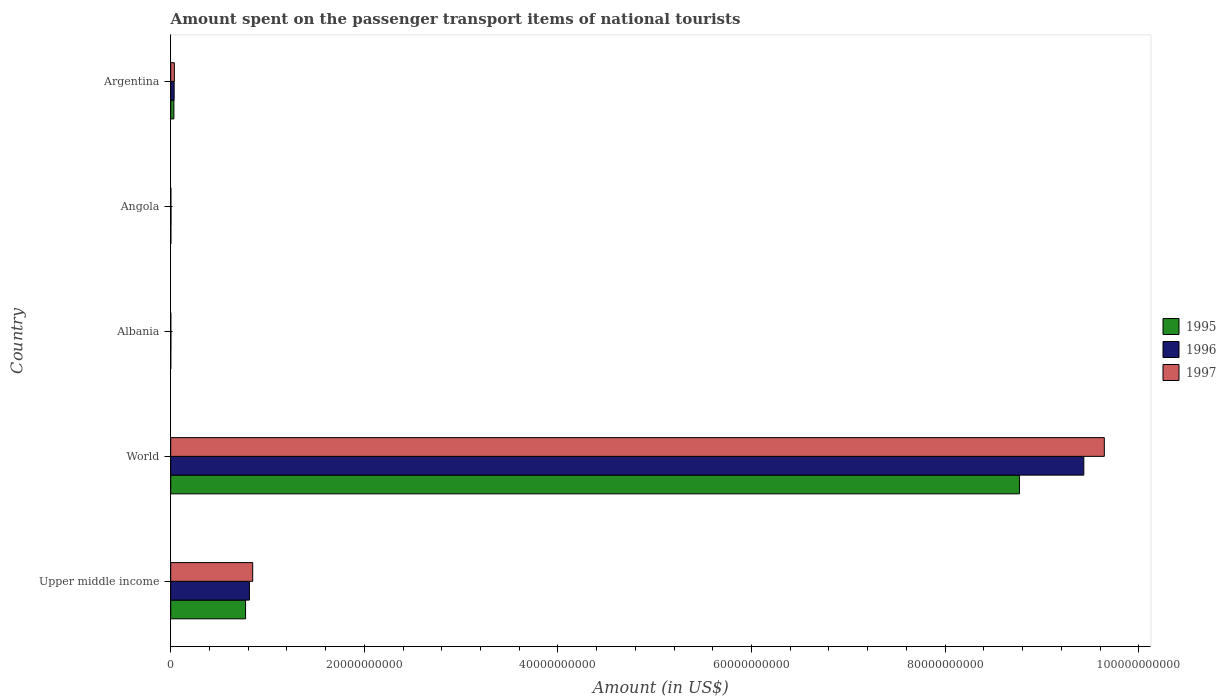How many different coloured bars are there?
Your response must be concise. 3. How many groups of bars are there?
Your answer should be compact. 5. What is the label of the 3rd group of bars from the top?
Offer a terse response. Albania. What is the amount spent on the passenger transport items of national tourists in 1997 in World?
Keep it short and to the point. 9.64e+1. Across all countries, what is the maximum amount spent on the passenger transport items of national tourists in 1996?
Ensure brevity in your answer.  9.43e+1. Across all countries, what is the minimum amount spent on the passenger transport items of national tourists in 1995?
Your answer should be very brief. 5.40e+06. In which country was the amount spent on the passenger transport items of national tourists in 1997 maximum?
Provide a short and direct response. World. In which country was the amount spent on the passenger transport items of national tourists in 1996 minimum?
Keep it short and to the point. Albania. What is the total amount spent on the passenger transport items of national tourists in 1995 in the graph?
Keep it short and to the point. 9.58e+1. What is the difference between the amount spent on the passenger transport items of national tourists in 1997 in Albania and that in World?
Make the answer very short. -9.64e+1. What is the difference between the amount spent on the passenger transport items of national tourists in 1995 in Albania and the amount spent on the passenger transport items of national tourists in 1996 in Upper middle income?
Provide a short and direct response. -8.13e+09. What is the average amount spent on the passenger transport items of national tourists in 1997 per country?
Make the answer very short. 2.11e+1. What is the difference between the amount spent on the passenger transport items of national tourists in 1995 and amount spent on the passenger transport items of national tourists in 1996 in Argentina?
Your response must be concise. -2.60e+07. In how many countries, is the amount spent on the passenger transport items of national tourists in 1996 greater than 72000000000 US$?
Provide a succinct answer. 1. What is the ratio of the amount spent on the passenger transport items of national tourists in 1996 in Albania to that in Upper middle income?
Keep it short and to the point. 0. Is the amount spent on the passenger transport items of national tourists in 1995 in Argentina less than that in World?
Your answer should be compact. Yes. Is the difference between the amount spent on the passenger transport items of national tourists in 1995 in Angola and Upper middle income greater than the difference between the amount spent on the passenger transport items of national tourists in 1996 in Angola and Upper middle income?
Your response must be concise. Yes. What is the difference between the highest and the second highest amount spent on the passenger transport items of national tourists in 1996?
Keep it short and to the point. 8.62e+1. What is the difference between the highest and the lowest amount spent on the passenger transport items of national tourists in 1995?
Your answer should be very brief. 8.77e+1. Is the sum of the amount spent on the passenger transport items of national tourists in 1996 in Albania and Upper middle income greater than the maximum amount spent on the passenger transport items of national tourists in 1995 across all countries?
Offer a very short reply. No. What does the 1st bar from the top in Albania represents?
Your answer should be compact. 1997. What does the 2nd bar from the bottom in Upper middle income represents?
Provide a succinct answer. 1996. Is it the case that in every country, the sum of the amount spent on the passenger transport items of national tourists in 1997 and amount spent on the passenger transport items of national tourists in 1996 is greater than the amount spent on the passenger transport items of national tourists in 1995?
Give a very brief answer. Yes. Are all the bars in the graph horizontal?
Provide a short and direct response. Yes. How many countries are there in the graph?
Make the answer very short. 5. Where does the legend appear in the graph?
Your response must be concise. Center right. How many legend labels are there?
Make the answer very short. 3. How are the legend labels stacked?
Offer a terse response. Vertical. What is the title of the graph?
Provide a succinct answer. Amount spent on the passenger transport items of national tourists. Does "1991" appear as one of the legend labels in the graph?
Keep it short and to the point. No. What is the label or title of the Y-axis?
Give a very brief answer. Country. What is the Amount (in US$) of 1995 in Upper middle income?
Provide a short and direct response. 7.73e+09. What is the Amount (in US$) in 1996 in Upper middle income?
Provide a short and direct response. 8.13e+09. What is the Amount (in US$) of 1997 in Upper middle income?
Your answer should be very brief. 8.47e+09. What is the Amount (in US$) in 1995 in World?
Your response must be concise. 8.77e+1. What is the Amount (in US$) of 1996 in World?
Make the answer very short. 9.43e+1. What is the Amount (in US$) of 1997 in World?
Offer a very short reply. 9.64e+1. What is the Amount (in US$) in 1995 in Albania?
Offer a terse response. 5.40e+06. What is the Amount (in US$) of 1996 in Albania?
Make the answer very short. 1.68e+07. What is the Amount (in US$) in 1997 in Albania?
Ensure brevity in your answer.  6.60e+06. What is the Amount (in US$) of 1995 in Angola?
Your answer should be very brief. 1.70e+07. What is the Amount (in US$) in 1996 in Angola?
Provide a succinct answer. 2.90e+07. What is the Amount (in US$) in 1997 in Angola?
Your answer should be compact. 1.50e+07. What is the Amount (in US$) of 1995 in Argentina?
Your answer should be very brief. 3.28e+08. What is the Amount (in US$) in 1996 in Argentina?
Provide a succinct answer. 3.54e+08. What is the Amount (in US$) of 1997 in Argentina?
Provide a succinct answer. 3.75e+08. Across all countries, what is the maximum Amount (in US$) of 1995?
Give a very brief answer. 8.77e+1. Across all countries, what is the maximum Amount (in US$) in 1996?
Make the answer very short. 9.43e+1. Across all countries, what is the maximum Amount (in US$) in 1997?
Ensure brevity in your answer.  9.64e+1. Across all countries, what is the minimum Amount (in US$) in 1995?
Give a very brief answer. 5.40e+06. Across all countries, what is the minimum Amount (in US$) in 1996?
Your answer should be compact. 1.68e+07. Across all countries, what is the minimum Amount (in US$) of 1997?
Offer a terse response. 6.60e+06. What is the total Amount (in US$) of 1995 in the graph?
Your answer should be compact. 9.58e+1. What is the total Amount (in US$) in 1996 in the graph?
Keep it short and to the point. 1.03e+11. What is the total Amount (in US$) of 1997 in the graph?
Provide a succinct answer. 1.05e+11. What is the difference between the Amount (in US$) in 1995 in Upper middle income and that in World?
Provide a short and direct response. -7.99e+1. What is the difference between the Amount (in US$) of 1996 in Upper middle income and that in World?
Make the answer very short. -8.62e+1. What is the difference between the Amount (in US$) of 1997 in Upper middle income and that in World?
Provide a succinct answer. -8.80e+1. What is the difference between the Amount (in US$) of 1995 in Upper middle income and that in Albania?
Provide a succinct answer. 7.73e+09. What is the difference between the Amount (in US$) in 1996 in Upper middle income and that in Albania?
Offer a terse response. 8.11e+09. What is the difference between the Amount (in US$) in 1997 in Upper middle income and that in Albania?
Provide a short and direct response. 8.46e+09. What is the difference between the Amount (in US$) of 1995 in Upper middle income and that in Angola?
Your response must be concise. 7.72e+09. What is the difference between the Amount (in US$) in 1996 in Upper middle income and that in Angola?
Offer a very short reply. 8.10e+09. What is the difference between the Amount (in US$) of 1997 in Upper middle income and that in Angola?
Keep it short and to the point. 8.45e+09. What is the difference between the Amount (in US$) of 1995 in Upper middle income and that in Argentina?
Your response must be concise. 7.41e+09. What is the difference between the Amount (in US$) in 1996 in Upper middle income and that in Argentina?
Ensure brevity in your answer.  7.78e+09. What is the difference between the Amount (in US$) in 1997 in Upper middle income and that in Argentina?
Provide a short and direct response. 8.09e+09. What is the difference between the Amount (in US$) of 1995 in World and that in Albania?
Offer a terse response. 8.77e+1. What is the difference between the Amount (in US$) in 1996 in World and that in Albania?
Make the answer very short. 9.43e+1. What is the difference between the Amount (in US$) of 1997 in World and that in Albania?
Provide a succinct answer. 9.64e+1. What is the difference between the Amount (in US$) in 1995 in World and that in Angola?
Offer a terse response. 8.77e+1. What is the difference between the Amount (in US$) of 1996 in World and that in Angola?
Your response must be concise. 9.43e+1. What is the difference between the Amount (in US$) of 1997 in World and that in Angola?
Provide a short and direct response. 9.64e+1. What is the difference between the Amount (in US$) of 1995 in World and that in Argentina?
Offer a very short reply. 8.73e+1. What is the difference between the Amount (in US$) of 1996 in World and that in Argentina?
Your answer should be compact. 9.40e+1. What is the difference between the Amount (in US$) of 1997 in World and that in Argentina?
Offer a very short reply. 9.61e+1. What is the difference between the Amount (in US$) in 1995 in Albania and that in Angola?
Give a very brief answer. -1.16e+07. What is the difference between the Amount (in US$) of 1996 in Albania and that in Angola?
Keep it short and to the point. -1.22e+07. What is the difference between the Amount (in US$) in 1997 in Albania and that in Angola?
Give a very brief answer. -8.40e+06. What is the difference between the Amount (in US$) in 1995 in Albania and that in Argentina?
Offer a terse response. -3.23e+08. What is the difference between the Amount (in US$) of 1996 in Albania and that in Argentina?
Your answer should be compact. -3.37e+08. What is the difference between the Amount (in US$) of 1997 in Albania and that in Argentina?
Offer a terse response. -3.69e+08. What is the difference between the Amount (in US$) of 1995 in Angola and that in Argentina?
Your response must be concise. -3.11e+08. What is the difference between the Amount (in US$) of 1996 in Angola and that in Argentina?
Your answer should be compact. -3.25e+08. What is the difference between the Amount (in US$) of 1997 in Angola and that in Argentina?
Keep it short and to the point. -3.60e+08. What is the difference between the Amount (in US$) in 1995 in Upper middle income and the Amount (in US$) in 1996 in World?
Your answer should be compact. -8.66e+1. What is the difference between the Amount (in US$) in 1995 in Upper middle income and the Amount (in US$) in 1997 in World?
Keep it short and to the point. -8.87e+1. What is the difference between the Amount (in US$) in 1996 in Upper middle income and the Amount (in US$) in 1997 in World?
Provide a succinct answer. -8.83e+1. What is the difference between the Amount (in US$) of 1995 in Upper middle income and the Amount (in US$) of 1996 in Albania?
Make the answer very short. 7.72e+09. What is the difference between the Amount (in US$) of 1995 in Upper middle income and the Amount (in US$) of 1997 in Albania?
Offer a terse response. 7.73e+09. What is the difference between the Amount (in US$) of 1996 in Upper middle income and the Amount (in US$) of 1997 in Albania?
Make the answer very short. 8.12e+09. What is the difference between the Amount (in US$) of 1995 in Upper middle income and the Amount (in US$) of 1996 in Angola?
Your answer should be very brief. 7.70e+09. What is the difference between the Amount (in US$) in 1995 in Upper middle income and the Amount (in US$) in 1997 in Angola?
Make the answer very short. 7.72e+09. What is the difference between the Amount (in US$) of 1996 in Upper middle income and the Amount (in US$) of 1997 in Angola?
Your answer should be very brief. 8.12e+09. What is the difference between the Amount (in US$) in 1995 in Upper middle income and the Amount (in US$) in 1996 in Argentina?
Make the answer very short. 7.38e+09. What is the difference between the Amount (in US$) of 1995 in Upper middle income and the Amount (in US$) of 1997 in Argentina?
Give a very brief answer. 7.36e+09. What is the difference between the Amount (in US$) of 1996 in Upper middle income and the Amount (in US$) of 1997 in Argentina?
Offer a terse response. 7.76e+09. What is the difference between the Amount (in US$) of 1995 in World and the Amount (in US$) of 1996 in Albania?
Your answer should be compact. 8.77e+1. What is the difference between the Amount (in US$) in 1995 in World and the Amount (in US$) in 1997 in Albania?
Give a very brief answer. 8.77e+1. What is the difference between the Amount (in US$) of 1996 in World and the Amount (in US$) of 1997 in Albania?
Offer a very short reply. 9.43e+1. What is the difference between the Amount (in US$) in 1995 in World and the Amount (in US$) in 1996 in Angola?
Ensure brevity in your answer.  8.76e+1. What is the difference between the Amount (in US$) in 1995 in World and the Amount (in US$) in 1997 in Angola?
Keep it short and to the point. 8.77e+1. What is the difference between the Amount (in US$) in 1996 in World and the Amount (in US$) in 1997 in Angola?
Offer a very short reply. 9.43e+1. What is the difference between the Amount (in US$) in 1995 in World and the Amount (in US$) in 1996 in Argentina?
Your answer should be very brief. 8.73e+1. What is the difference between the Amount (in US$) in 1995 in World and the Amount (in US$) in 1997 in Argentina?
Your response must be concise. 8.73e+1. What is the difference between the Amount (in US$) in 1996 in World and the Amount (in US$) in 1997 in Argentina?
Offer a very short reply. 9.39e+1. What is the difference between the Amount (in US$) of 1995 in Albania and the Amount (in US$) of 1996 in Angola?
Provide a succinct answer. -2.36e+07. What is the difference between the Amount (in US$) of 1995 in Albania and the Amount (in US$) of 1997 in Angola?
Offer a very short reply. -9.60e+06. What is the difference between the Amount (in US$) in 1996 in Albania and the Amount (in US$) in 1997 in Angola?
Give a very brief answer. 1.80e+06. What is the difference between the Amount (in US$) in 1995 in Albania and the Amount (in US$) in 1996 in Argentina?
Ensure brevity in your answer.  -3.49e+08. What is the difference between the Amount (in US$) of 1995 in Albania and the Amount (in US$) of 1997 in Argentina?
Make the answer very short. -3.70e+08. What is the difference between the Amount (in US$) in 1996 in Albania and the Amount (in US$) in 1997 in Argentina?
Provide a short and direct response. -3.59e+08. What is the difference between the Amount (in US$) of 1995 in Angola and the Amount (in US$) of 1996 in Argentina?
Give a very brief answer. -3.37e+08. What is the difference between the Amount (in US$) in 1995 in Angola and the Amount (in US$) in 1997 in Argentina?
Your response must be concise. -3.58e+08. What is the difference between the Amount (in US$) of 1996 in Angola and the Amount (in US$) of 1997 in Argentina?
Make the answer very short. -3.46e+08. What is the average Amount (in US$) in 1995 per country?
Provide a short and direct response. 1.92e+1. What is the average Amount (in US$) of 1996 per country?
Provide a succinct answer. 2.06e+1. What is the average Amount (in US$) in 1997 per country?
Your answer should be very brief. 2.11e+1. What is the difference between the Amount (in US$) in 1995 and Amount (in US$) in 1996 in Upper middle income?
Give a very brief answer. -3.97e+08. What is the difference between the Amount (in US$) of 1995 and Amount (in US$) of 1997 in Upper middle income?
Give a very brief answer. -7.36e+08. What is the difference between the Amount (in US$) of 1996 and Amount (in US$) of 1997 in Upper middle income?
Give a very brief answer. -3.39e+08. What is the difference between the Amount (in US$) of 1995 and Amount (in US$) of 1996 in World?
Keep it short and to the point. -6.65e+09. What is the difference between the Amount (in US$) of 1995 and Amount (in US$) of 1997 in World?
Give a very brief answer. -8.77e+09. What is the difference between the Amount (in US$) of 1996 and Amount (in US$) of 1997 in World?
Your answer should be very brief. -2.12e+09. What is the difference between the Amount (in US$) in 1995 and Amount (in US$) in 1996 in Albania?
Make the answer very short. -1.14e+07. What is the difference between the Amount (in US$) of 1995 and Amount (in US$) of 1997 in Albania?
Provide a succinct answer. -1.20e+06. What is the difference between the Amount (in US$) in 1996 and Amount (in US$) in 1997 in Albania?
Your answer should be very brief. 1.02e+07. What is the difference between the Amount (in US$) in 1995 and Amount (in US$) in 1996 in Angola?
Offer a terse response. -1.20e+07. What is the difference between the Amount (in US$) of 1996 and Amount (in US$) of 1997 in Angola?
Provide a succinct answer. 1.40e+07. What is the difference between the Amount (in US$) of 1995 and Amount (in US$) of 1996 in Argentina?
Your answer should be very brief. -2.60e+07. What is the difference between the Amount (in US$) of 1995 and Amount (in US$) of 1997 in Argentina?
Give a very brief answer. -4.74e+07. What is the difference between the Amount (in US$) of 1996 and Amount (in US$) of 1997 in Argentina?
Offer a very short reply. -2.14e+07. What is the ratio of the Amount (in US$) in 1995 in Upper middle income to that in World?
Provide a short and direct response. 0.09. What is the ratio of the Amount (in US$) in 1996 in Upper middle income to that in World?
Give a very brief answer. 0.09. What is the ratio of the Amount (in US$) in 1997 in Upper middle income to that in World?
Keep it short and to the point. 0.09. What is the ratio of the Amount (in US$) of 1995 in Upper middle income to that in Albania?
Your answer should be compact. 1432.19. What is the ratio of the Amount (in US$) of 1996 in Upper middle income to that in Albania?
Ensure brevity in your answer.  483.97. What is the ratio of the Amount (in US$) in 1997 in Upper middle income to that in Albania?
Keep it short and to the point. 1283.31. What is the ratio of the Amount (in US$) in 1995 in Upper middle income to that in Angola?
Your answer should be compact. 454.93. What is the ratio of the Amount (in US$) of 1996 in Upper middle income to that in Angola?
Give a very brief answer. 280.37. What is the ratio of the Amount (in US$) in 1997 in Upper middle income to that in Angola?
Keep it short and to the point. 564.66. What is the ratio of the Amount (in US$) in 1995 in Upper middle income to that in Argentina?
Your response must be concise. 23.58. What is the ratio of the Amount (in US$) in 1996 in Upper middle income to that in Argentina?
Your answer should be compact. 22.97. What is the ratio of the Amount (in US$) of 1997 in Upper middle income to that in Argentina?
Give a very brief answer. 22.56. What is the ratio of the Amount (in US$) in 1995 in World to that in Albania?
Give a very brief answer. 1.62e+04. What is the ratio of the Amount (in US$) in 1996 in World to that in Albania?
Offer a very short reply. 5614.52. What is the ratio of the Amount (in US$) of 1997 in World to that in Albania?
Your answer should be very brief. 1.46e+04. What is the ratio of the Amount (in US$) in 1995 in World to that in Angola?
Ensure brevity in your answer.  5157.3. What is the ratio of the Amount (in US$) in 1996 in World to that in Angola?
Your answer should be very brief. 3252.55. What is the ratio of the Amount (in US$) of 1997 in World to that in Angola?
Make the answer very short. 6429.47. What is the ratio of the Amount (in US$) in 1995 in World to that in Argentina?
Your response must be concise. 267.3. What is the ratio of the Amount (in US$) of 1996 in World to that in Argentina?
Your answer should be compact. 266.45. What is the ratio of the Amount (in US$) of 1997 in World to that in Argentina?
Provide a short and direct response. 256.9. What is the ratio of the Amount (in US$) of 1995 in Albania to that in Angola?
Your response must be concise. 0.32. What is the ratio of the Amount (in US$) of 1996 in Albania to that in Angola?
Your answer should be very brief. 0.58. What is the ratio of the Amount (in US$) of 1997 in Albania to that in Angola?
Your answer should be very brief. 0.44. What is the ratio of the Amount (in US$) of 1995 in Albania to that in Argentina?
Offer a terse response. 0.02. What is the ratio of the Amount (in US$) of 1996 in Albania to that in Argentina?
Your answer should be compact. 0.05. What is the ratio of the Amount (in US$) of 1997 in Albania to that in Argentina?
Offer a terse response. 0.02. What is the ratio of the Amount (in US$) of 1995 in Angola to that in Argentina?
Keep it short and to the point. 0.05. What is the ratio of the Amount (in US$) in 1996 in Angola to that in Argentina?
Provide a short and direct response. 0.08. What is the difference between the highest and the second highest Amount (in US$) of 1995?
Keep it short and to the point. 7.99e+1. What is the difference between the highest and the second highest Amount (in US$) of 1996?
Make the answer very short. 8.62e+1. What is the difference between the highest and the second highest Amount (in US$) in 1997?
Give a very brief answer. 8.80e+1. What is the difference between the highest and the lowest Amount (in US$) of 1995?
Your answer should be very brief. 8.77e+1. What is the difference between the highest and the lowest Amount (in US$) in 1996?
Your answer should be very brief. 9.43e+1. What is the difference between the highest and the lowest Amount (in US$) of 1997?
Ensure brevity in your answer.  9.64e+1. 